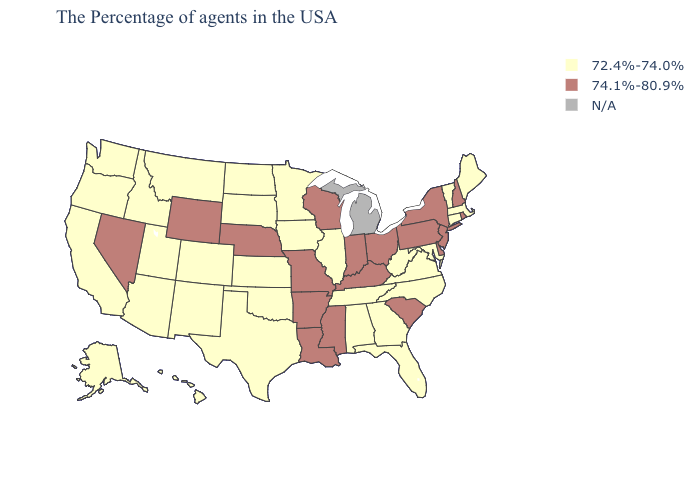Name the states that have a value in the range N/A?
Quick response, please. Michigan. Name the states that have a value in the range 72.4%-74.0%?
Keep it brief. Maine, Massachusetts, Vermont, Connecticut, Maryland, Virginia, North Carolina, West Virginia, Florida, Georgia, Alabama, Tennessee, Illinois, Minnesota, Iowa, Kansas, Oklahoma, Texas, South Dakota, North Dakota, Colorado, New Mexico, Utah, Montana, Arizona, Idaho, California, Washington, Oregon, Alaska, Hawaii. What is the value of South Dakota?
Short answer required. 72.4%-74.0%. What is the value of Illinois?
Quick response, please. 72.4%-74.0%. Does Alaska have the highest value in the USA?
Keep it brief. No. Name the states that have a value in the range 74.1%-80.9%?
Be succinct. Rhode Island, New Hampshire, New York, New Jersey, Delaware, Pennsylvania, South Carolina, Ohio, Kentucky, Indiana, Wisconsin, Mississippi, Louisiana, Missouri, Arkansas, Nebraska, Wyoming, Nevada. Is the legend a continuous bar?
Concise answer only. No. Which states hav the highest value in the MidWest?
Keep it brief. Ohio, Indiana, Wisconsin, Missouri, Nebraska. What is the value of Vermont?
Give a very brief answer. 72.4%-74.0%. What is the value of Missouri?
Short answer required. 74.1%-80.9%. What is the highest value in the Northeast ?
Quick response, please. 74.1%-80.9%. Does Missouri have the lowest value in the USA?
Give a very brief answer. No. Among the states that border Idaho , which have the highest value?
Write a very short answer. Wyoming, Nevada. 